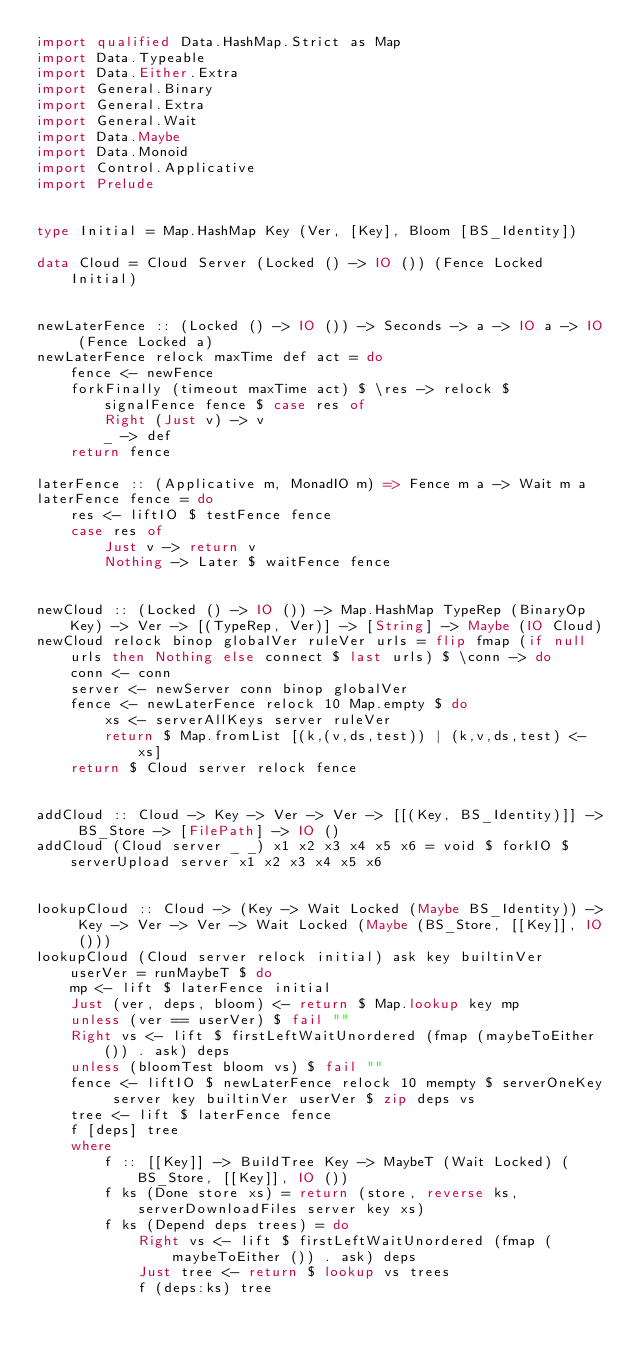<code> <loc_0><loc_0><loc_500><loc_500><_Haskell_>import qualified Data.HashMap.Strict as Map
import Data.Typeable
import Data.Either.Extra
import General.Binary
import General.Extra
import General.Wait
import Data.Maybe
import Data.Monoid
import Control.Applicative
import Prelude


type Initial = Map.HashMap Key (Ver, [Key], Bloom [BS_Identity])

data Cloud = Cloud Server (Locked () -> IO ()) (Fence Locked Initial)


newLaterFence :: (Locked () -> IO ()) -> Seconds -> a -> IO a -> IO (Fence Locked a)
newLaterFence relock maxTime def act = do
    fence <- newFence
    forkFinally (timeout maxTime act) $ \res -> relock $ signalFence fence $ case res of
        Right (Just v) -> v
        _ -> def
    return fence

laterFence :: (Applicative m, MonadIO m) => Fence m a -> Wait m a
laterFence fence = do
    res <- liftIO $ testFence fence
    case res of
        Just v -> return v
        Nothing -> Later $ waitFence fence


newCloud :: (Locked () -> IO ()) -> Map.HashMap TypeRep (BinaryOp Key) -> Ver -> [(TypeRep, Ver)] -> [String] -> Maybe (IO Cloud)
newCloud relock binop globalVer ruleVer urls = flip fmap (if null urls then Nothing else connect $ last urls) $ \conn -> do
    conn <- conn
    server <- newServer conn binop globalVer
    fence <- newLaterFence relock 10 Map.empty $ do
        xs <- serverAllKeys server ruleVer
        return $ Map.fromList [(k,(v,ds,test)) | (k,v,ds,test) <- xs]
    return $ Cloud server relock fence


addCloud :: Cloud -> Key -> Ver -> Ver -> [[(Key, BS_Identity)]] -> BS_Store -> [FilePath] -> IO ()
addCloud (Cloud server _ _) x1 x2 x3 x4 x5 x6 = void $ forkIO $ serverUpload server x1 x2 x3 x4 x5 x6


lookupCloud :: Cloud -> (Key -> Wait Locked (Maybe BS_Identity)) -> Key -> Ver -> Ver -> Wait Locked (Maybe (BS_Store, [[Key]], IO ()))
lookupCloud (Cloud server relock initial) ask key builtinVer userVer = runMaybeT $ do
    mp <- lift $ laterFence initial
    Just (ver, deps, bloom) <- return $ Map.lookup key mp
    unless (ver == userVer) $ fail ""
    Right vs <- lift $ firstLeftWaitUnordered (fmap (maybeToEither ()) . ask) deps
    unless (bloomTest bloom vs) $ fail ""
    fence <- liftIO $ newLaterFence relock 10 mempty $ serverOneKey server key builtinVer userVer $ zip deps vs
    tree <- lift $ laterFence fence
    f [deps] tree
    where
        f :: [[Key]] -> BuildTree Key -> MaybeT (Wait Locked) (BS_Store, [[Key]], IO ())
        f ks (Done store xs) = return (store, reverse ks, serverDownloadFiles server key xs)
        f ks (Depend deps trees) = do
            Right vs <- lift $ firstLeftWaitUnordered (fmap (maybeToEither ()) . ask) deps
            Just tree <- return $ lookup vs trees
            f (deps:ks) tree
</code> 